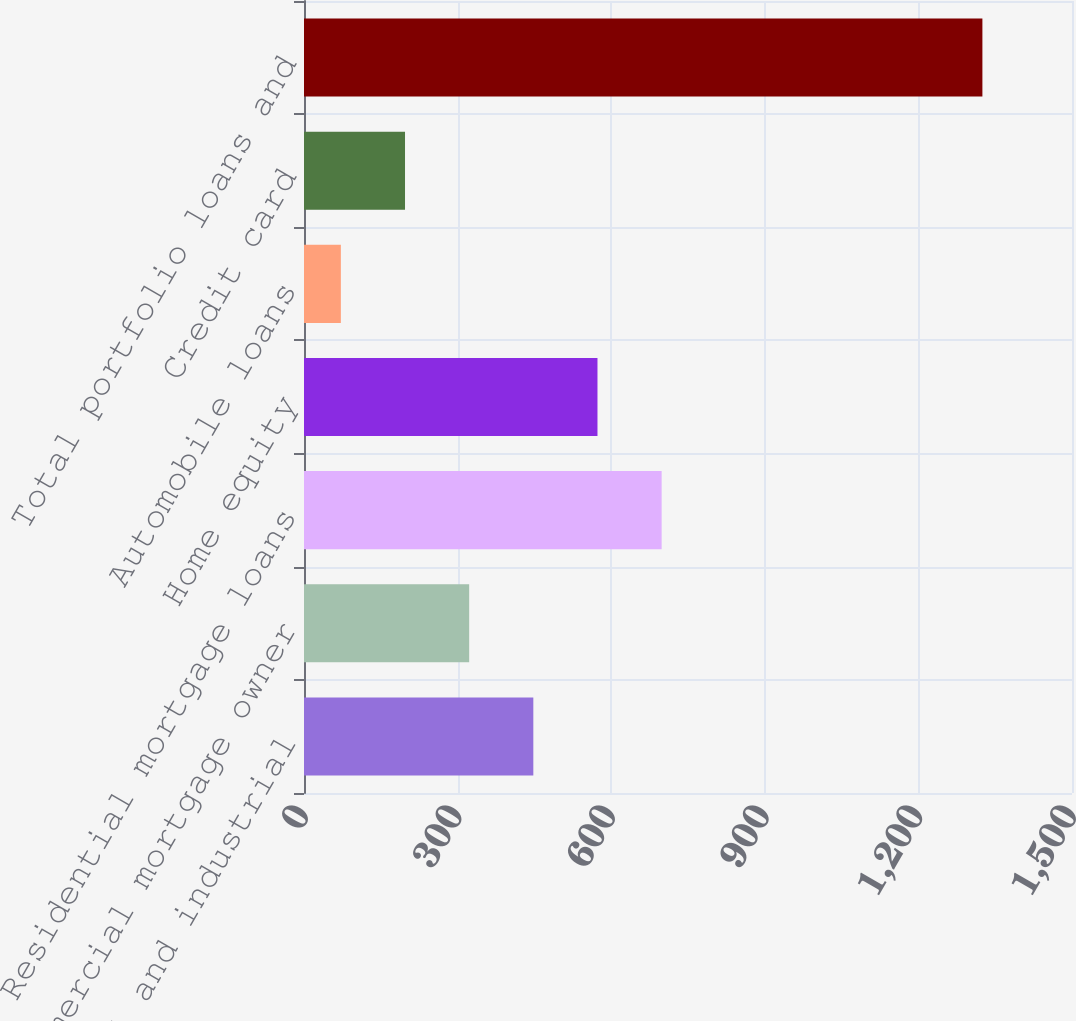Convert chart. <chart><loc_0><loc_0><loc_500><loc_500><bar_chart><fcel>Commercial and industrial<fcel>Commercial mortgage owner<fcel>Residential mortgage loans<fcel>Home equity<fcel>Automobile loans<fcel>Credit card<fcel>Total portfolio loans and<nl><fcel>447.9<fcel>322.6<fcel>698.5<fcel>573.2<fcel>72<fcel>197.3<fcel>1325<nl></chart> 